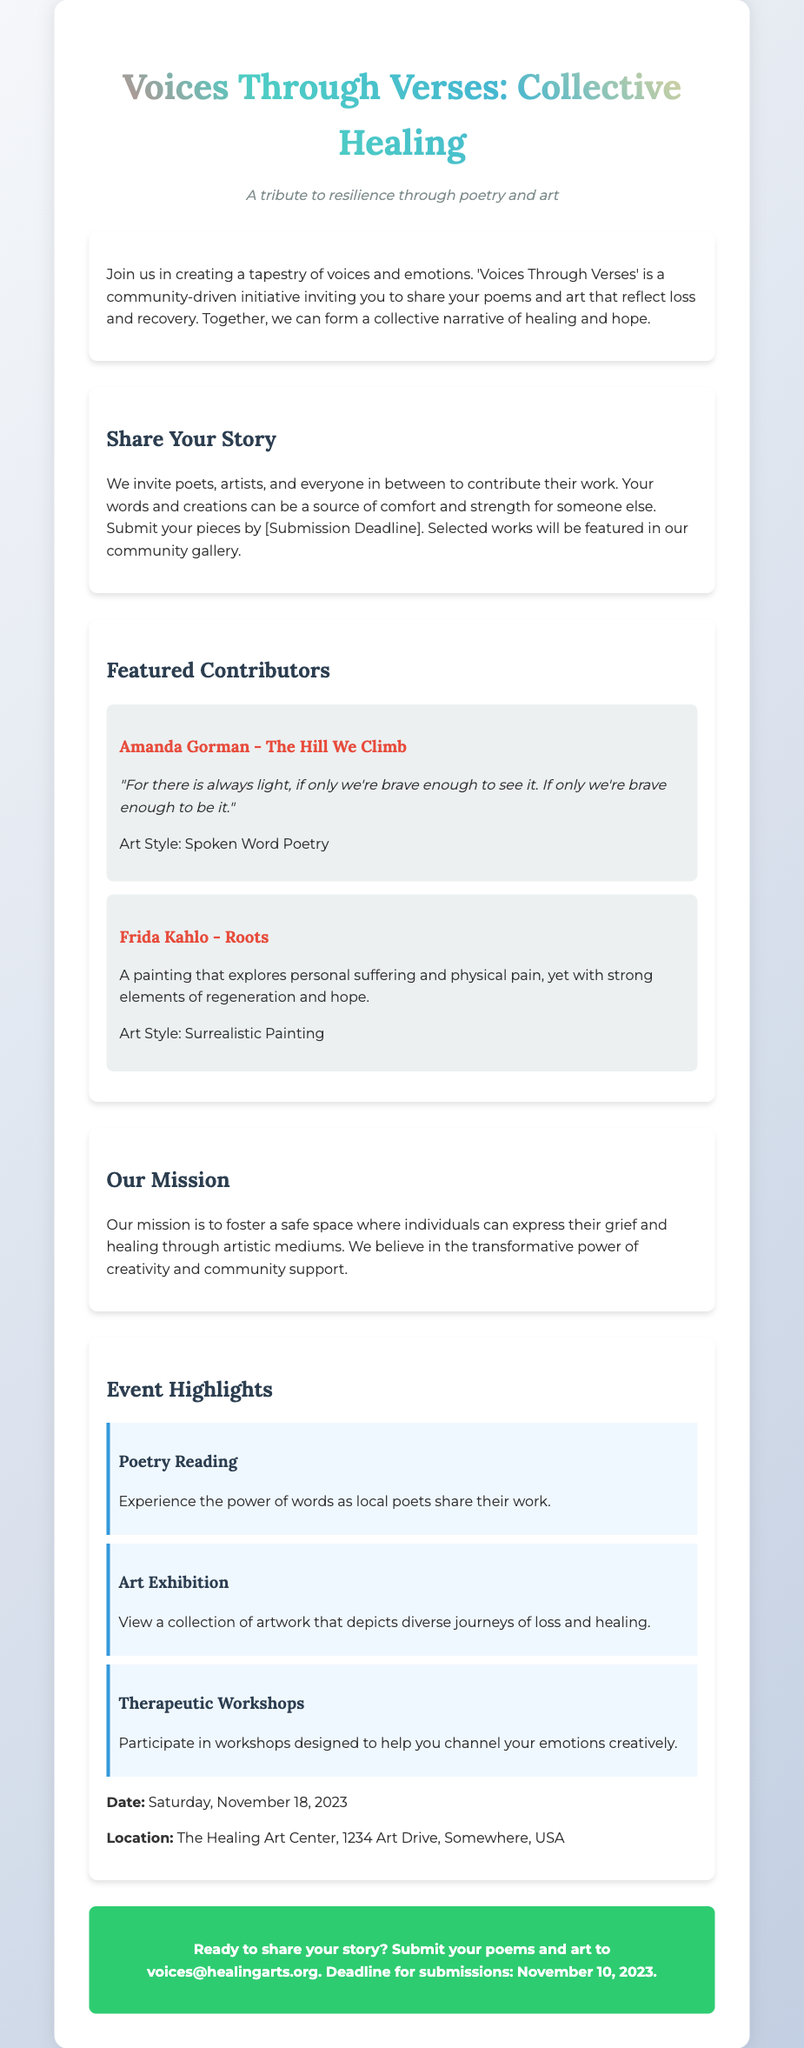What is the title of the poster? The title of the poster is prominently featured at the top of the document.
Answer: Voices Through Verses: Collective Healing What is the submission deadline for contributions? The submission deadline is mentioned in the call to action in the document.
Answer: November 10, 2023 Where will the event take place? The location of the event is specified in the event highlights section of the document.
Answer: The Healing Art Center, 1234 Art Drive, Somewhere, USA What is the date of the event? The date of the event is clearly stated in the event highlights section of the poster.
Answer: Saturday, November 18, 2023 What type of art style did Amanda Gorman use? The art style used by Amanda Gorman is noted in her contributor section.
Answer: Spoken Word Poetry What is the main mission of the initiative? The mission of the initiative is explained in a dedicated section of the poster.
Answer: Foster a safe space for expression How many event highlights are listed in the document? The number of event highlights is counted in the event highlights section.
Answer: Three What does the tagline emphasize? The tagline provides a theme that encapsulates the purpose of the initiative.
Answer: Resilience through poetry and art What type of creative works does the poster invite? The poster invites specific types of contributions mentioned in the call to action section.
Answer: Poems and art 